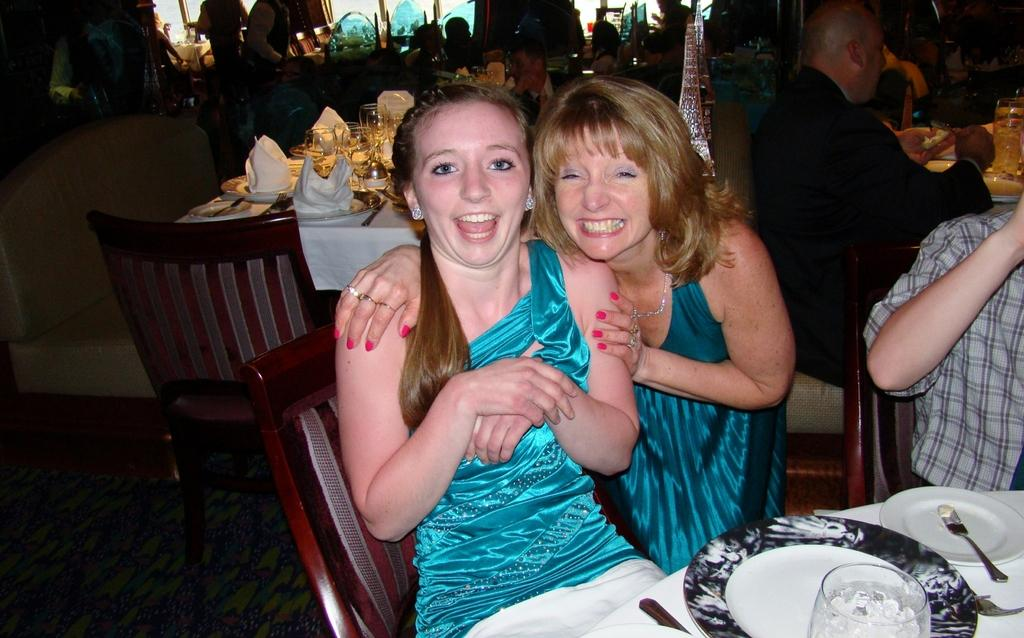How many people are in the image? There is a group of people in the image. What are the people doing in the image? The people are sitting in front of a table. What objects can be seen on the table? There is a glass, a plate, and spoons on the table. How many dogs are sitting on the table in the image? There are no dogs present in the image; it only shows a group of people sitting in front of a table with a glass, a plate, and spoons. 